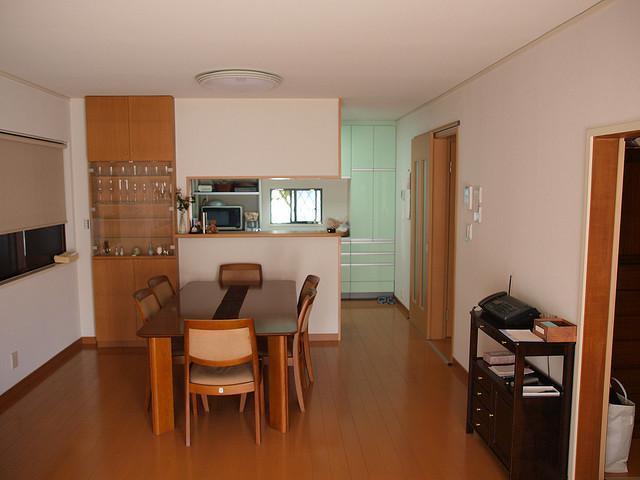How many chairs are in the picture?
Give a very brief answer. 6. How many tables are in the room?
Give a very brief answer. 2. How many chairs are there?
Give a very brief answer. 2. 